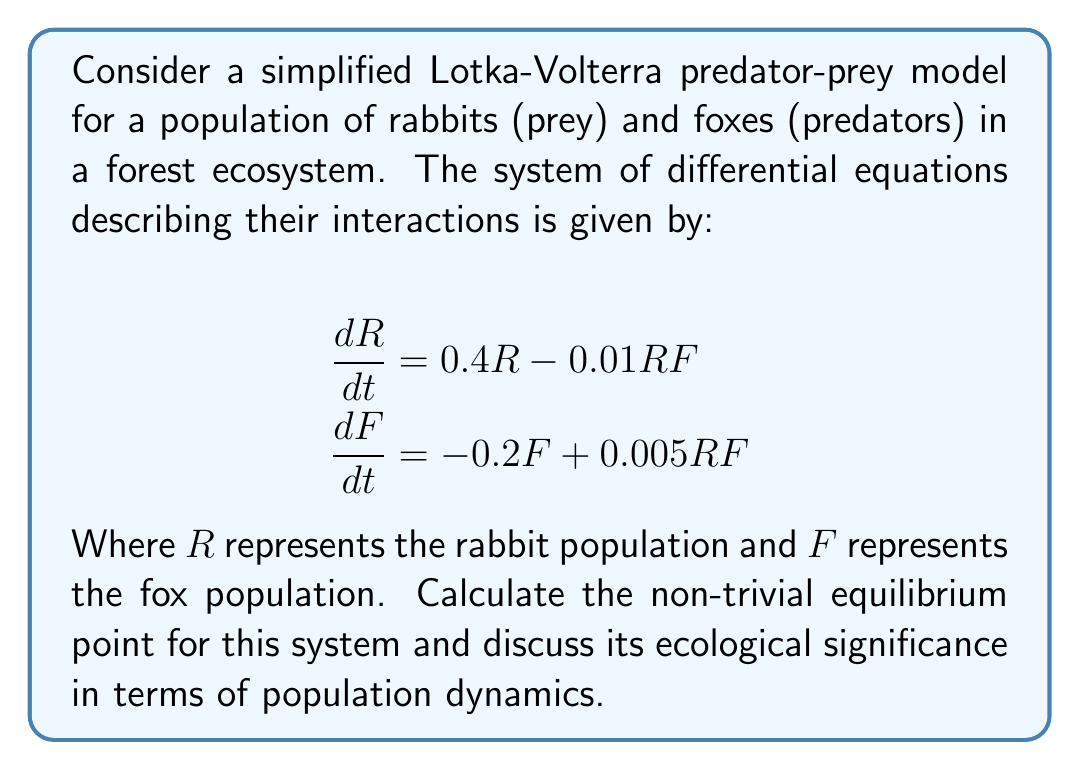Show me your answer to this math problem. To find the equilibrium point, we need to set both differential equations to zero and solve for $R$ and $F$:

1) Set $\frac{dR}{dt} = 0$ and $\frac{dF}{dt} = 0$:

   $$\begin{align}
   0 &= 0.4R - 0.01RF \\
   0 &= -0.2F + 0.005RF
   \end{align}$$

2) From the first equation:
   
   $$0.4R - 0.01RF = 0$$
   $$R(0.4 - 0.01F) = 0$$

   This gives us two possibilities: $R = 0$ or $0.4 - 0.01F = 0$. 
   We're interested in the non-trivial solution, so:

   $$0.4 - 0.01F = 0$$
   $$F = 40$$

3) From the second equation:

   $$-0.2F + 0.005RF = 0$$
   $$F(-0.2 + 0.005R) = 0$$

   Again, for the non-trivial solution:

   $$-0.2 + 0.005R = 0$$
   $$R = 40$$

4) Therefore, the non-trivial equilibrium point is $(R, F) = (40, 40)$.

Ecological significance:
This equilibrium point represents a stable coexistence of predator and prey populations. At this point, the rabbit population grows at a rate that exactly balances the rate at which they are being consumed by foxes, while the fox population's death rate is balanced by their reproduction rate based on rabbit consumption. This demonstrates how predator-prey relationships can lead to stable ecosystems over time, which is crucial for understanding population dynamics in real-world scenarios.
Answer: The non-trivial equilibrium point is $(R, F) = (40, 40)$. 